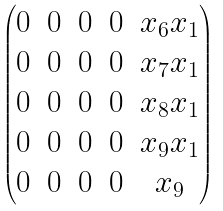Convert formula to latex. <formula><loc_0><loc_0><loc_500><loc_500>\begin{pmatrix} 0 & 0 & 0 & 0 & x _ { 6 } x _ { 1 } \\ 0 & 0 & 0 & 0 & x _ { 7 } x _ { 1 } \\ 0 & 0 & 0 & 0 & x _ { 8 } x _ { 1 } \\ 0 & 0 & 0 & 0 & x _ { 9 } x _ { 1 } \\ 0 & 0 & 0 & 0 & x _ { 9 } \end{pmatrix}</formula> 